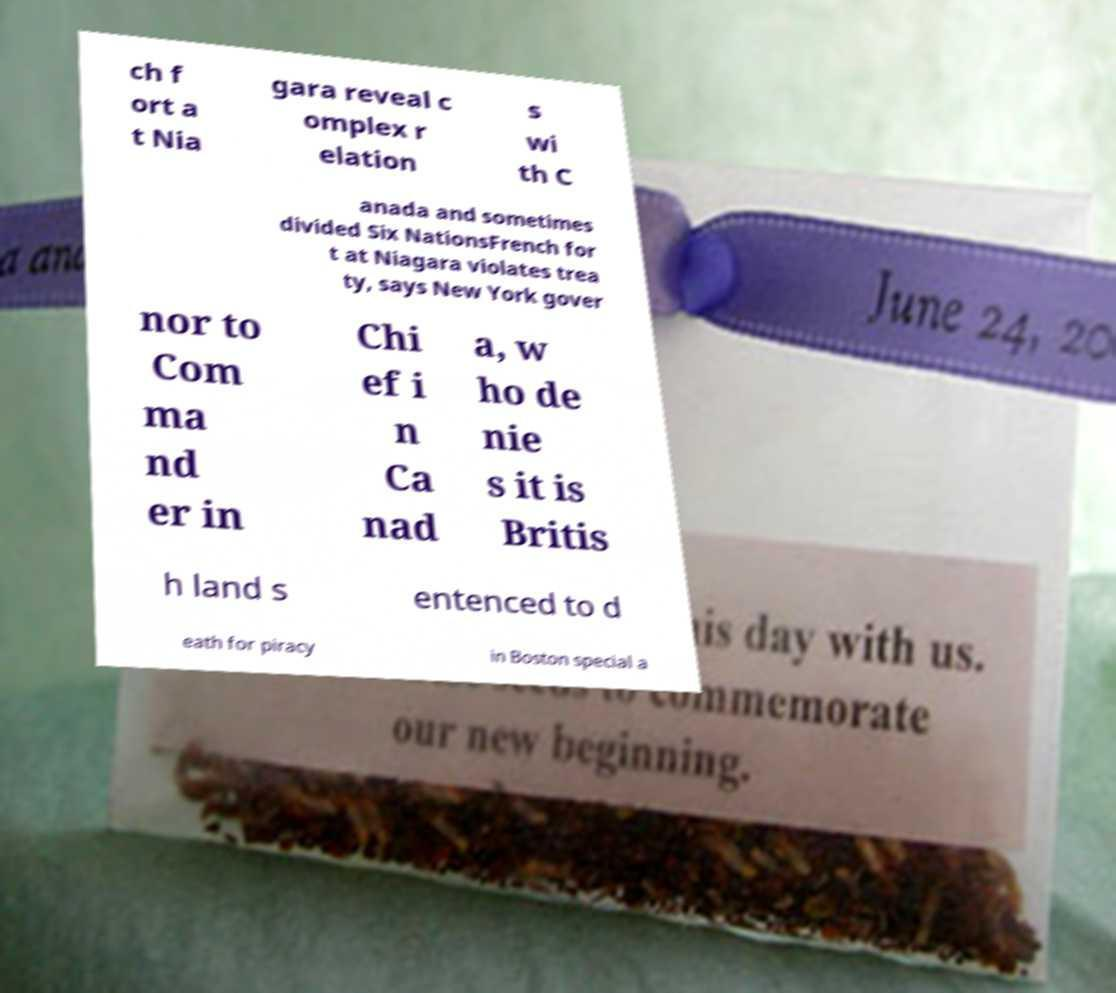Please identify and transcribe the text found in this image. ch f ort a t Nia gara reveal c omplex r elation s wi th C anada and sometimes divided Six NationsFrench for t at Niagara violates trea ty, says New York gover nor to Com ma nd er in Chi ef i n Ca nad a, w ho de nie s it is Britis h land s entenced to d eath for piracy in Boston special a 